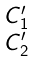<formula> <loc_0><loc_0><loc_500><loc_500>\begin{smallmatrix} C ^ { \prime } _ { 1 } \\ C ^ { \prime } _ { 2 } \end{smallmatrix}</formula> 